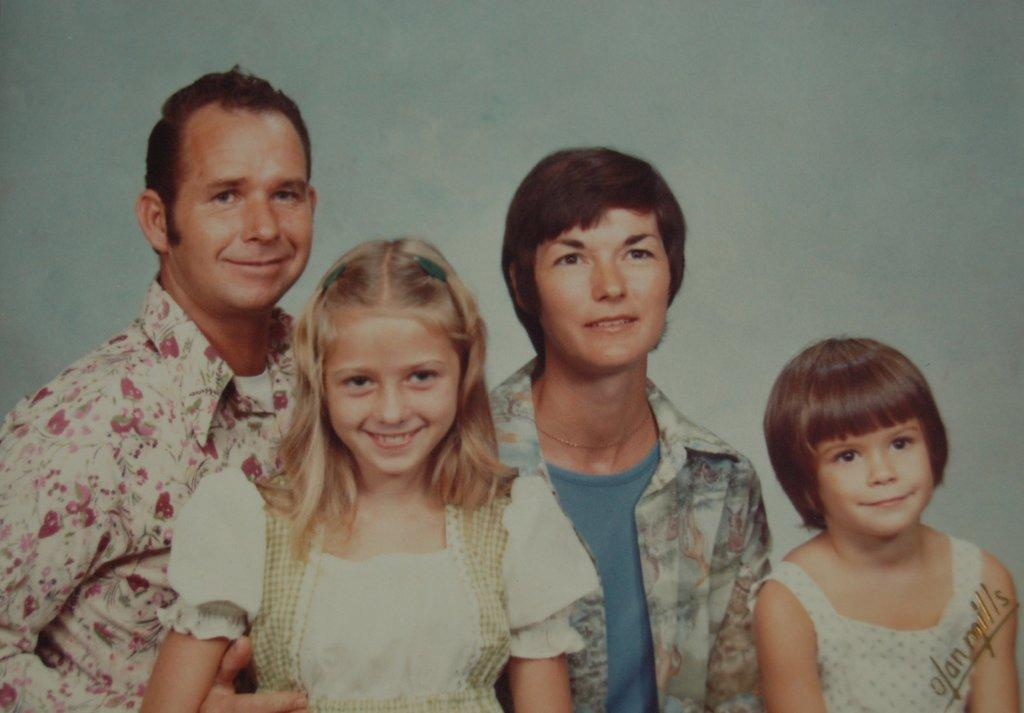How many people are present in the image? There are four people in the image. Can you describe the expressions on the faces of the people? Some of the people are smiling. Is there any text visible in the image? Yes, there is text in the bottom right-hand corner of the image. What type of volleyball game is being played in the image? There is no volleyball game present in the image. In which country is the image taken? The provided facts do not mention the country where the image was taken. 